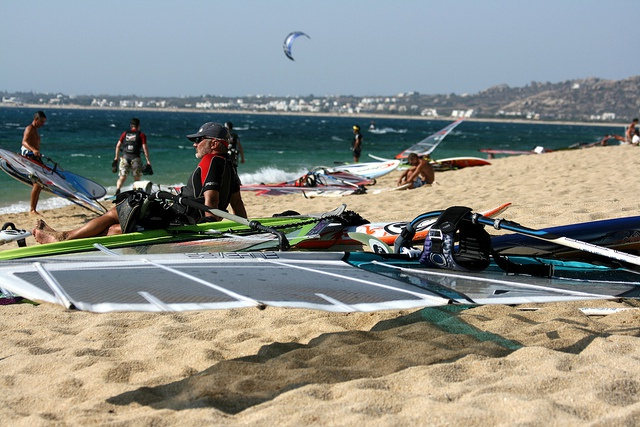Describe the objects in this image and their specific colors. I can see people in lightblue, black, gray, brown, and maroon tones, surfboard in lightblue, darkgreen, black, green, and lightgreen tones, people in lightblue, black, gray, maroon, and teal tones, people in lightblue, black, maroon, and brown tones, and people in lightblue, maroon, black, and brown tones in this image. 